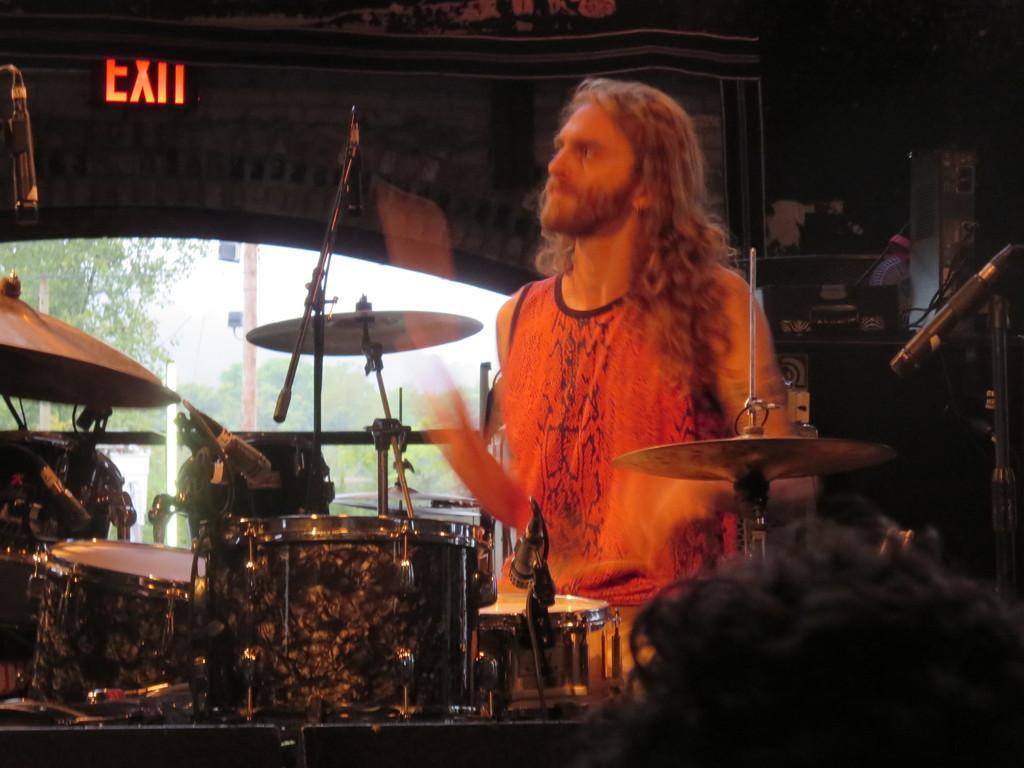Please provide a concise description of this image. In this image, I can see a person standing. In front of the person there are drums, cymbals, hi-hat instrument and miles with the mike stands. Behind the person, I can see few objects. In the background, I can see trees, poles and the sky through a window. At the top left side of the image, there is an exit board. 